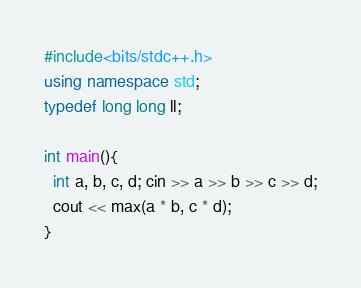Convert code to text. <code><loc_0><loc_0><loc_500><loc_500><_C++_>#include<bits/stdc++.h>
using namespace std;
typedef long long ll;

int main(){
  int a, b, c, d; cin >> a >> b >> c >> d;
  cout << max(a * b, c * d);
}</code> 